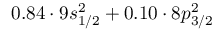Convert formula to latex. <formula><loc_0><loc_0><loc_500><loc_500>0 . 8 4 \cdot 9 s _ { 1 / 2 } ^ { 2 } + 0 . 1 0 \cdot 8 p _ { 3 / 2 } ^ { 2 }</formula> 